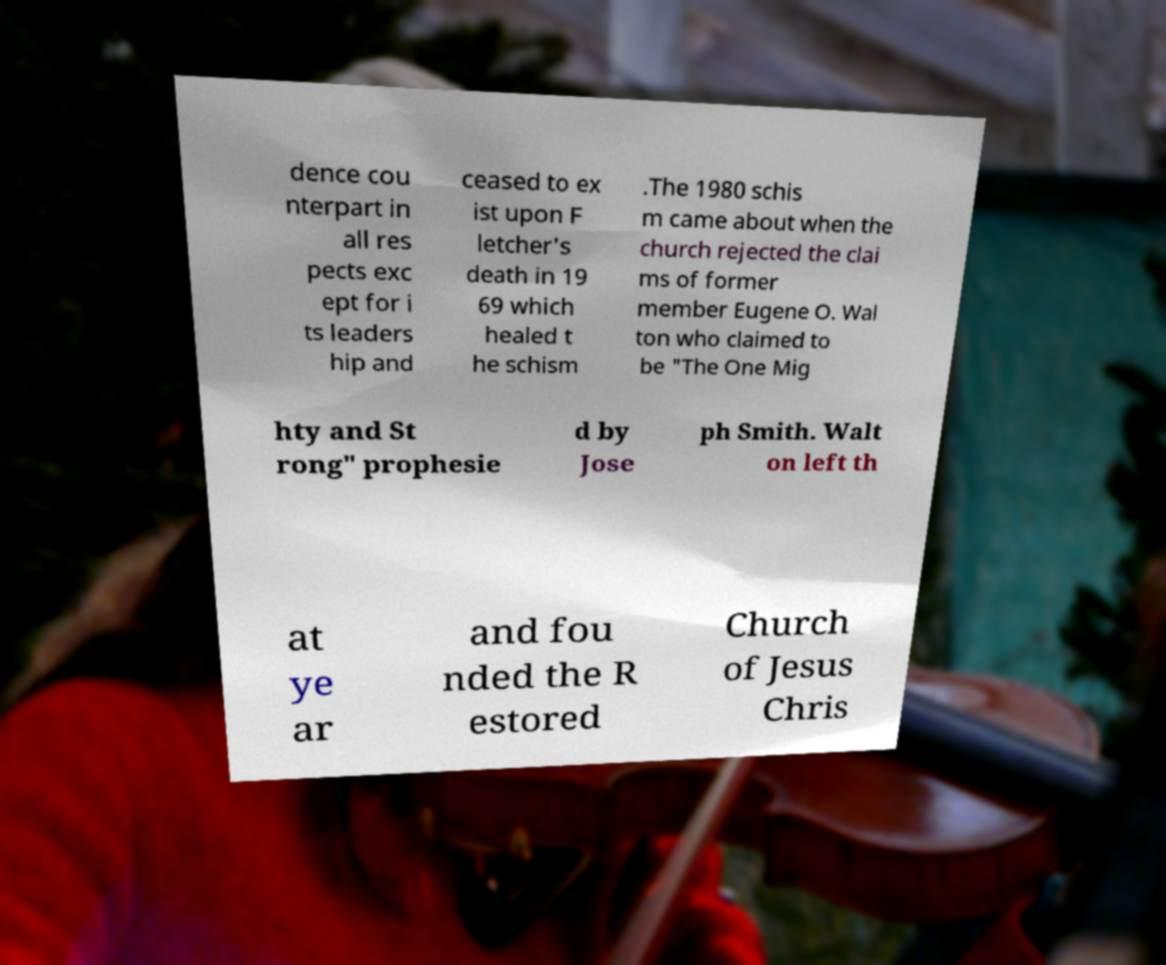Please read and relay the text visible in this image. What does it say? dence cou nterpart in all res pects exc ept for i ts leaders hip and ceased to ex ist upon F letcher's death in 19 69 which healed t he schism .The 1980 schis m came about when the church rejected the clai ms of former member Eugene O. Wal ton who claimed to be "The One Mig hty and St rong" prophesie d by Jose ph Smith. Walt on left th at ye ar and fou nded the R estored Church of Jesus Chris 